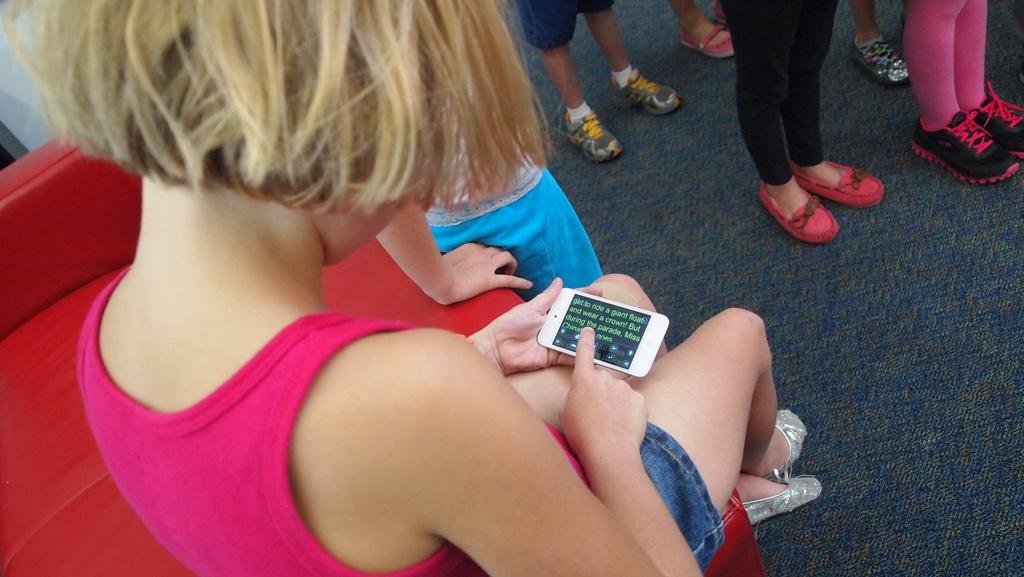What is the main subject of the image? The main subject of the image is a group of people. Can you describe the position of one of the individuals in the group? There is a girl sitting on a chair. What is the girl holding in her hand? The girl is holding a phone. What type of disgust can be seen on the girl's face in the image? There is no indication of disgust on the girl's face in the image. 